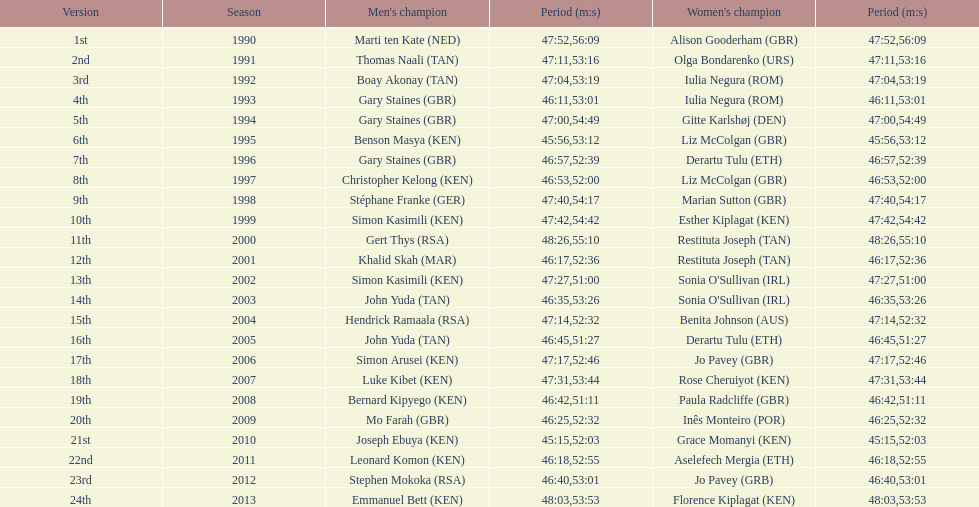Is there any woman swifter than any man? No. 